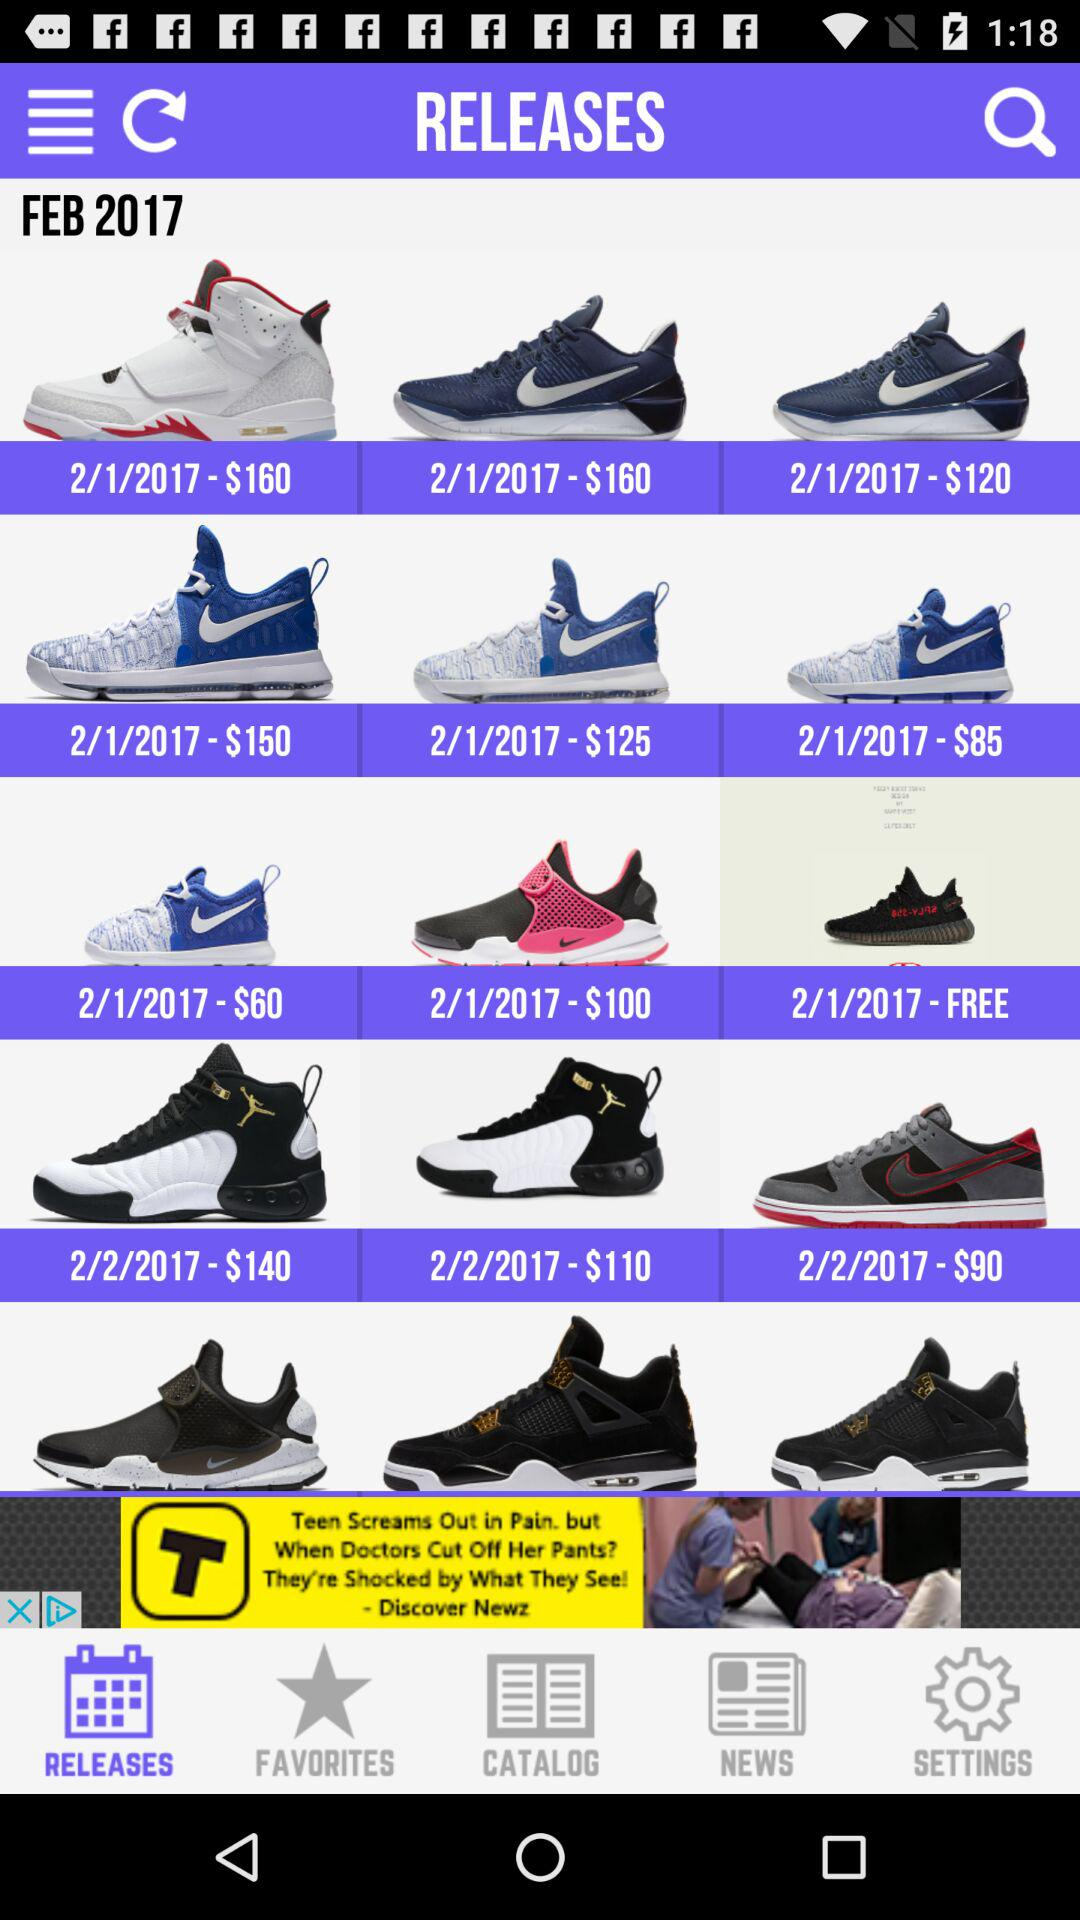How many shoes are priced below $100?
Answer the question using a single word or phrase. 3 